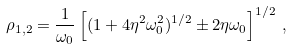<formula> <loc_0><loc_0><loc_500><loc_500>\rho _ { 1 , 2 } = \frac { 1 } { \omega _ { 0 } } \left [ ( 1 + 4 \eta ^ { 2 } \omega _ { 0 } ^ { 2 } ) ^ { 1 / 2 } \pm 2 \eta \omega _ { 0 } \right ] ^ { 1 / 2 } \, ,</formula> 